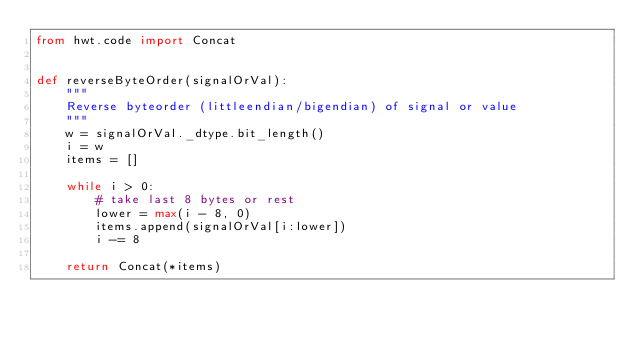Convert code to text. <code><loc_0><loc_0><loc_500><loc_500><_Python_>from hwt.code import Concat


def reverseByteOrder(signalOrVal):
    """
    Reverse byteorder (littleendian/bigendian) of signal or value
    """
    w = signalOrVal._dtype.bit_length()
    i = w
    items = []

    while i > 0:
        # take last 8 bytes or rest
        lower = max(i - 8, 0)
        items.append(signalOrVal[i:lower])
        i -= 8

    return Concat(*items)
</code> 